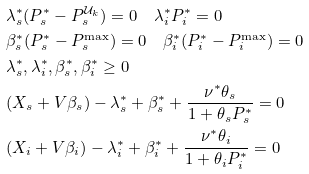<formula> <loc_0><loc_0><loc_500><loc_500>& \lambda _ { s } ^ { * } ( P _ { s } ^ { * } - P _ { s } ^ { \mathcal { U } _ { k } } ) = 0 \quad \lambda _ { i } ^ { * } P _ { i } ^ { * } = 0 \\ & \beta _ { s } ^ { * } ( P _ { s } ^ { * } - P _ { s } ^ { \max } ) = 0 \quad \beta _ { i } ^ { * } ( P _ { i } ^ { * } - P _ { i } ^ { \max } ) = 0 \\ & \lambda _ { s } ^ { * } , \lambda _ { i } ^ { * } , \beta _ { s } ^ { * } , \beta _ { i } ^ { * } \geq 0 \\ & ( X _ { s } + V \beta _ { s } ) - \lambda _ { s } ^ { * } + \beta _ { s } ^ { * } + \frac { \nu ^ { * } \theta _ { s } } { 1 + \theta _ { s } P _ { s } ^ { * } } = 0 \\ & ( X _ { i } + V \beta _ { i } ) - \lambda _ { i } ^ { * } + \beta _ { i } ^ { * } + \frac { \nu ^ { * } \theta _ { i } } { 1 + \theta _ { i } P _ { i } ^ { * } } = 0</formula> 